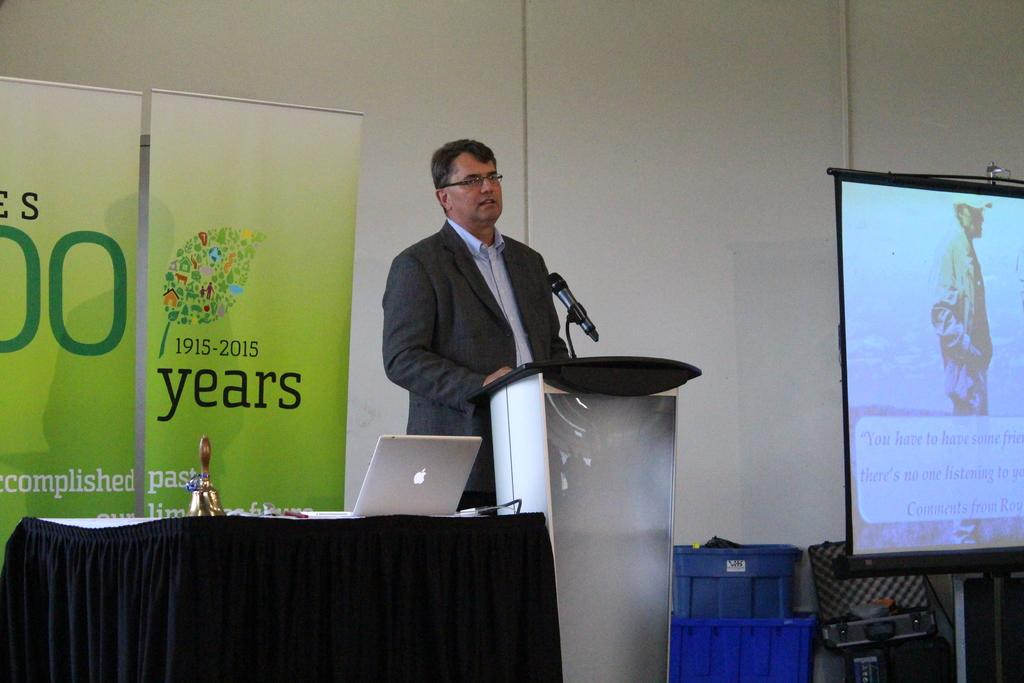<image>
Summarize the visual content of the image. a man speaking in front of a green sign with 1915-2015 years on it 